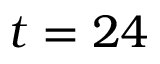<formula> <loc_0><loc_0><loc_500><loc_500>t = 2 4</formula> 